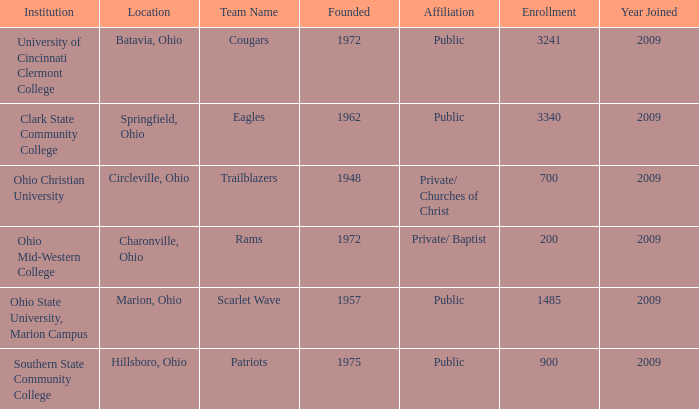What is the affiliation when the institution was ohio christian university? Private/ Churches of Christ. 